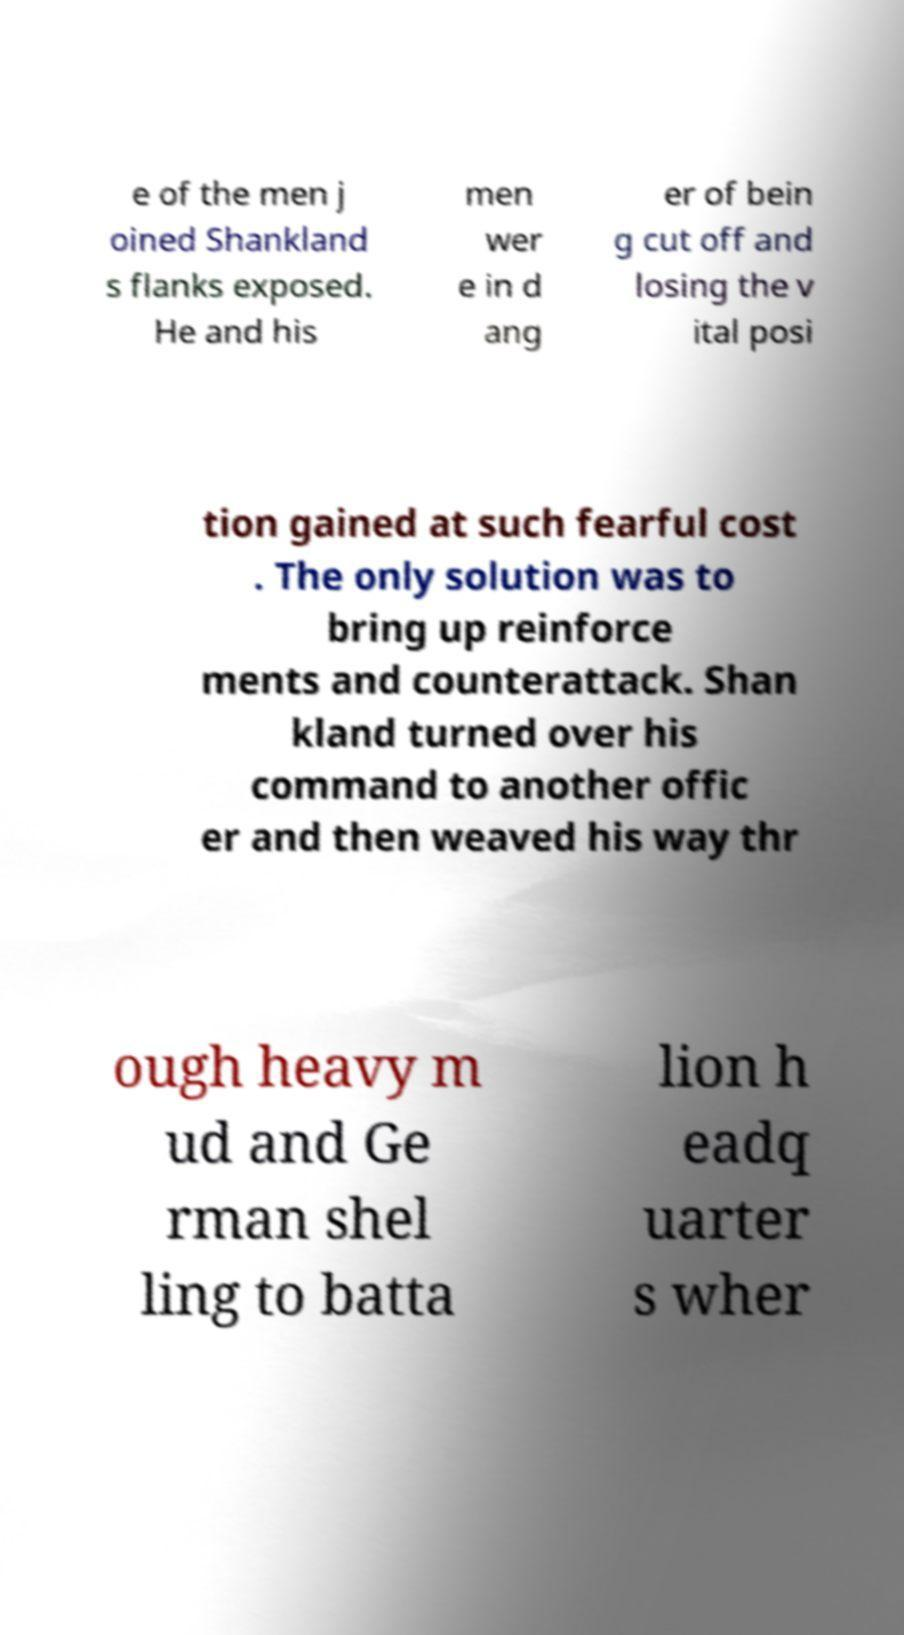For documentation purposes, I need the text within this image transcribed. Could you provide that? e of the men j oined Shankland s flanks exposed. He and his men wer e in d ang er of bein g cut off and losing the v ital posi tion gained at such fearful cost . The only solution was to bring up reinforce ments and counterattack. Shan kland turned over his command to another offic er and then weaved his way thr ough heavy m ud and Ge rman shel ling to batta lion h eadq uarter s wher 